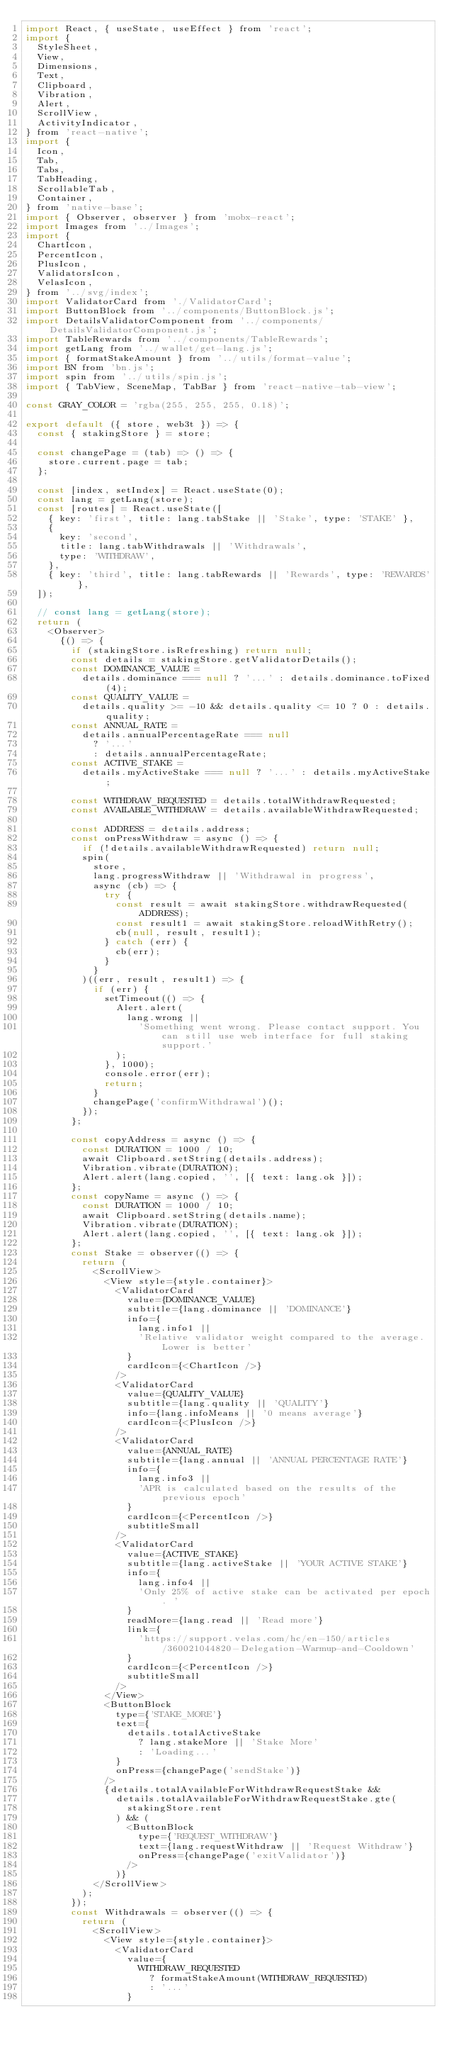Convert code to text. <code><loc_0><loc_0><loc_500><loc_500><_JavaScript_>import React, { useState, useEffect } from 'react';
import {
  StyleSheet,
  View,
  Dimensions,
  Text,
  Clipboard,
  Vibration,
  Alert,
  ScrollView,
  ActivityIndicator,
} from 'react-native';
import {
  Icon,
  Tab,
  Tabs,
  TabHeading,
  ScrollableTab,
  Container,
} from 'native-base';
import { Observer, observer } from 'mobx-react';
import Images from '../Images';
import {
  ChartIcon,
  PercentIcon,
  PlusIcon,
  ValidatorsIcon,
  VelasIcon,
} from '../svg/index';
import ValidatorCard from './ValidatorCard';
import ButtonBlock from '../components/ButtonBlock.js';
import DetailsValidatorComponent from '../components/DetailsValidatorComponent.js';
import TableRewards from '../components/TableRewards';
import getLang from '../wallet/get-lang.js';
import { formatStakeAmount } from '../utils/format-value';
import BN from 'bn.js';
import spin from '../utils/spin.js';
import { TabView, SceneMap, TabBar } from 'react-native-tab-view';

const GRAY_COLOR = 'rgba(255, 255, 255, 0.18)';

export default ({ store, web3t }) => {
  const { stakingStore } = store;

  const changePage = (tab) => () => {
    store.current.page = tab;
  };

  const [index, setIndex] = React.useState(0);
  const lang = getLang(store);
  const [routes] = React.useState([
    { key: 'first', title: lang.tabStake || 'Stake', type: 'STAKE' },
    {
      key: 'second',
      title: lang.tabWithdrawals || 'Withdrawals',
      type: 'WITHDRAW',
    },
    { key: 'third', title: lang.tabRewards || 'Rewards', type: 'REWARDS' },
  ]);

  // const lang = getLang(store);
  return (
    <Observer>
      {() => {
        if (stakingStore.isRefreshing) return null;
        const details = stakingStore.getValidatorDetails();
        const DOMINANCE_VALUE =
          details.dominance === null ? '...' : details.dominance.toFixed(4);
        const QUALITY_VALUE =
          details.quality >= -10 && details.quality <= 10 ? 0 : details.quality;
        const ANNUAL_RATE =
          details.annualPercentageRate === null
            ? '...'
            : details.annualPercentageRate;
        const ACTIVE_STAKE =
          details.myActiveStake === null ? '...' : details.myActiveStake;

        const WITHDRAW_REQUESTED = details.totalWithdrawRequested;
        const AVAILABLE_WITHDRAW = details.availableWithdrawRequested;

        const ADDRESS = details.address;
        const onPressWithdraw = async () => {
          if (!details.availableWithdrawRequested) return null;
          spin(
            store,
            lang.progressWithdraw || 'Withdrawal in progress',
            async (cb) => {
              try {
                const result = await stakingStore.withdrawRequested(ADDRESS);
                const result1 = await stakingStore.reloadWithRetry();
                cb(null, result, result1);
              } catch (err) {
                cb(err);
              }
            }
          )((err, result, result1) => {
            if (err) {
              setTimeout(() => {
                Alert.alert(
                  lang.wrong ||
                    'Something went wrong. Please contact support. You can still use web interface for full staking support.'
                );
              }, 1000);
              console.error(err);
              return;
            }
            changePage('confirmWithdrawal')();
          });
        };

        const copyAddress = async () => {
          const DURATION = 1000 / 10;
          await Clipboard.setString(details.address);
          Vibration.vibrate(DURATION);
          Alert.alert(lang.copied, '', [{ text: lang.ok }]);
        };
        const copyName = async () => {
          const DURATION = 1000 / 10;
          await Clipboard.setString(details.name);
          Vibration.vibrate(DURATION);
          Alert.alert(lang.copied, '', [{ text: lang.ok }]);
        };
        const Stake = observer(() => {
          return (
            <ScrollView>
              <View style={style.container}>
                <ValidatorCard
                  value={DOMINANCE_VALUE}
                  subtitle={lang.dominance || 'DOMINANCE'}
                  info={
                    lang.info1 ||
                    'Relative validator weight compared to the average. Lower is better'
                  }
                  cardIcon={<ChartIcon />}
                />
                <ValidatorCard
                  value={QUALITY_VALUE}
                  subtitle={lang.quality || 'QUALITY'}
                  info={lang.infoMeans || '0 means average'}
                  cardIcon={<PlusIcon />}
                />
                <ValidatorCard
                  value={ANNUAL_RATE}
                  subtitle={lang.annual || 'ANNUAL PERCENTAGE RATE'}
                  info={
                    lang.info3 ||
                    'APR is calculated based on the results of the previous epoch'
                  }
                  cardIcon={<PercentIcon />}
                  subtitleSmall
                />
                <ValidatorCard
                  value={ACTIVE_STAKE}
                  subtitle={lang.activeStake || 'YOUR ACTIVE STAKE'}
                  info={
                    lang.info4 ||
                    'Only 25% of active stake can be activated per epoch. '
                  }
                  readMore={lang.read || 'Read more'}
                  link={
                    'https://support.velas.com/hc/en-150/articles/360021044820-Delegation-Warmup-and-Cooldown'
                  }
                  cardIcon={<PercentIcon />}
                  subtitleSmall
                />
              </View>
              <ButtonBlock
                type={'STAKE_MORE'}
                text={
                  details.totalActiveStake
                    ? lang.stakeMore || 'Stake More'
                    : 'Loading...'
                }
                onPress={changePage('sendStake')}
              />
              {details.totalAvailableForWithdrawRequestStake &&
                details.totalAvailableForWithdrawRequestStake.gte(
                  stakingStore.rent
                ) && (
                  <ButtonBlock
                    type={'REQUEST_WITHDRAW'}
                    text={lang.requestWithdraw || 'Request Withdraw'}
                    onPress={changePage('exitValidator')}
                  />
                )}
            </ScrollView>
          );
        });
        const Withdrawals = observer(() => {
          return (
            <ScrollView>
              <View style={style.container}>
                <ValidatorCard
                  value={
                    WITHDRAW_REQUESTED
                      ? formatStakeAmount(WITHDRAW_REQUESTED)
                      : '...'
                  }</code> 